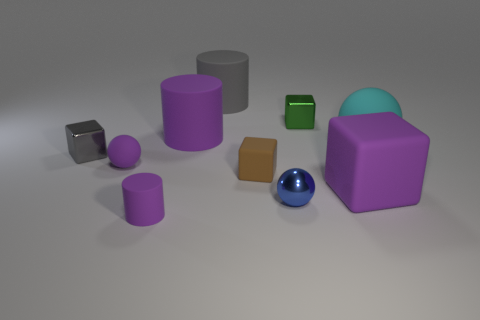Subtract all small balls. How many balls are left? 1 Subtract all cylinders. How many objects are left? 7 Subtract 1 balls. How many balls are left? 2 Subtract all brown balls. Subtract all blue cylinders. How many balls are left? 3 Subtract all cyan balls. How many cyan blocks are left? 0 Subtract all small purple rubber balls. Subtract all purple blocks. How many objects are left? 8 Add 8 gray matte cylinders. How many gray matte cylinders are left? 9 Add 4 large green shiny blocks. How many large green shiny blocks exist? 4 Subtract all purple blocks. How many blocks are left? 3 Subtract 0 blue cubes. How many objects are left? 10 